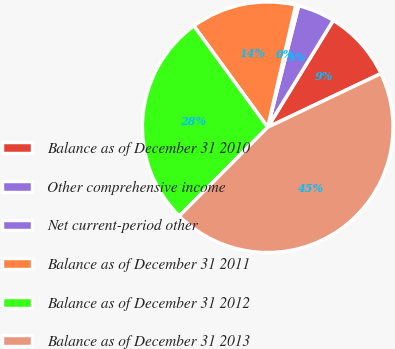Convert chart to OTSL. <chart><loc_0><loc_0><loc_500><loc_500><pie_chart><fcel>Balance as of December 31 2010<fcel>Other comprehensive income<fcel>Net current-period other<fcel>Balance as of December 31 2011<fcel>Balance as of December 31 2012<fcel>Balance as of December 31 2013<nl><fcel>9.2%<fcel>4.79%<fcel>0.38%<fcel>13.62%<fcel>27.5%<fcel>44.51%<nl></chart> 